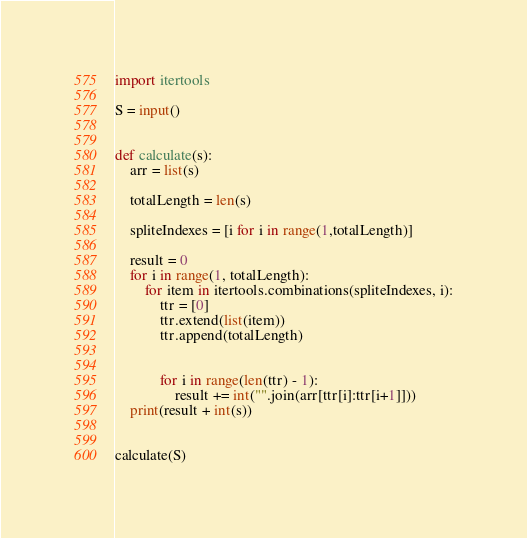Convert code to text. <code><loc_0><loc_0><loc_500><loc_500><_Python_>import itertools

S = input()


def calculate(s):
    arr = list(s)

    totalLength = len(s)

    spliteIndexes = [i for i in range(1,totalLength)]

    result = 0
    for i in range(1, totalLength):
        for item in itertools.combinations(spliteIndexes, i):
            ttr = [0]
            ttr.extend(list(item))
            ttr.append(totalLength)


            for i in range(len(ttr) - 1):
                result += int("".join(arr[ttr[i]:ttr[i+1]]))
    print(result + int(s))


calculate(S)


</code> 